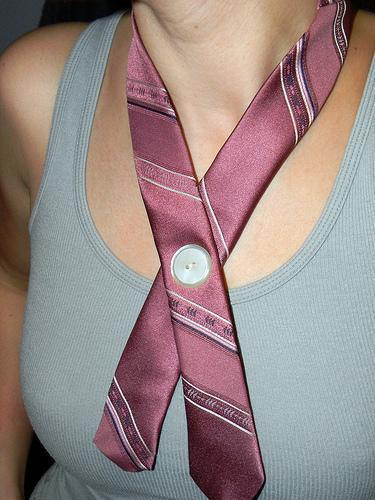How many people are in this picture?
Give a very brief answer. 1. How many people are wearing necklace?
Give a very brief answer. 0. 